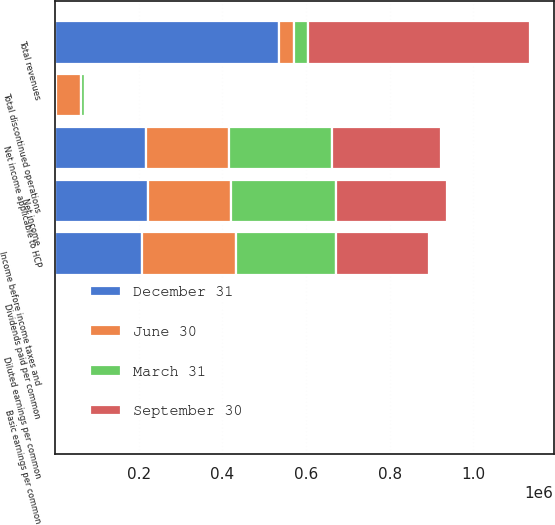<chart> <loc_0><loc_0><loc_500><loc_500><stacked_bar_chart><ecel><fcel>Total revenues<fcel>Income before income taxes and<fcel>Net income<fcel>Net income applicable to HCP<fcel>Dividends paid per common<fcel>Basic earnings per common<fcel>Diluted earnings per common<fcel>Total discontinued operations<nl><fcel>September 30<fcel>529992<fcel>220795<fcel>263623<fcel>259111<fcel>0.55<fcel>0.56<fcel>0.56<fcel>2232<nl><fcel>December 31<fcel>536121<fcel>208926<fcel>222279<fcel>218885<fcel>0.55<fcel>0.48<fcel>0.48<fcel>2828<nl><fcel>March 31<fcel>34656.5<fcel>240946<fcel>251059<fcel>247654<fcel>0.55<fcel>0.54<fcel>0.54<fcel>9824<nl><fcel>June 30<fcel>34656.5<fcel>222771<fcel>199630<fcel>196583<fcel>0.55<fcel>0.43<fcel>0.43<fcel>59489<nl></chart> 